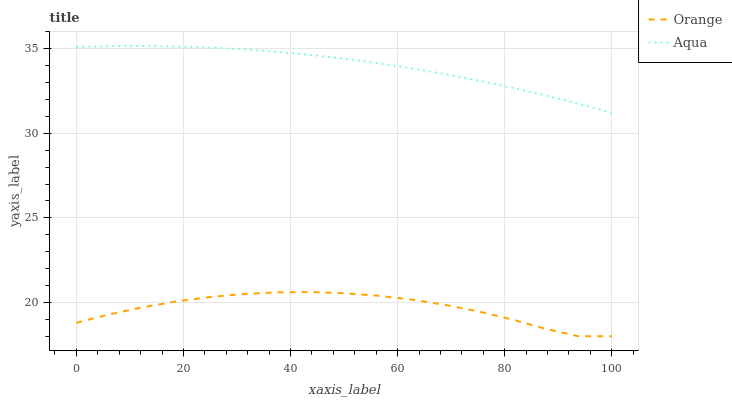Does Orange have the minimum area under the curve?
Answer yes or no. Yes. Does Aqua have the maximum area under the curve?
Answer yes or no. Yes. Does Aqua have the minimum area under the curve?
Answer yes or no. No. Is Aqua the smoothest?
Answer yes or no. Yes. Is Orange the roughest?
Answer yes or no. Yes. Is Aqua the roughest?
Answer yes or no. No. Does Orange have the lowest value?
Answer yes or no. Yes. Does Aqua have the lowest value?
Answer yes or no. No. Does Aqua have the highest value?
Answer yes or no. Yes. Is Orange less than Aqua?
Answer yes or no. Yes. Is Aqua greater than Orange?
Answer yes or no. Yes. Does Orange intersect Aqua?
Answer yes or no. No. 